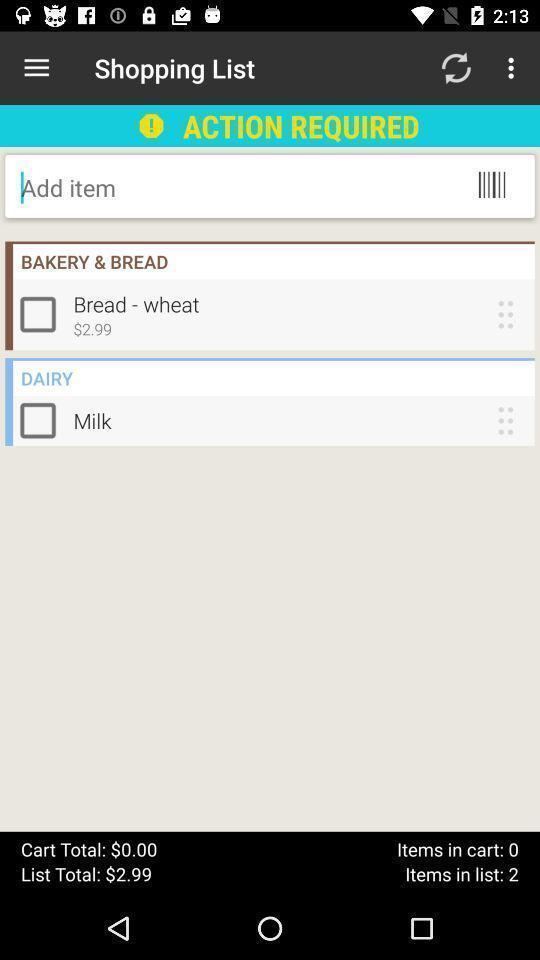What details can you identify in this image? Shopping app page with products to add in cart. 